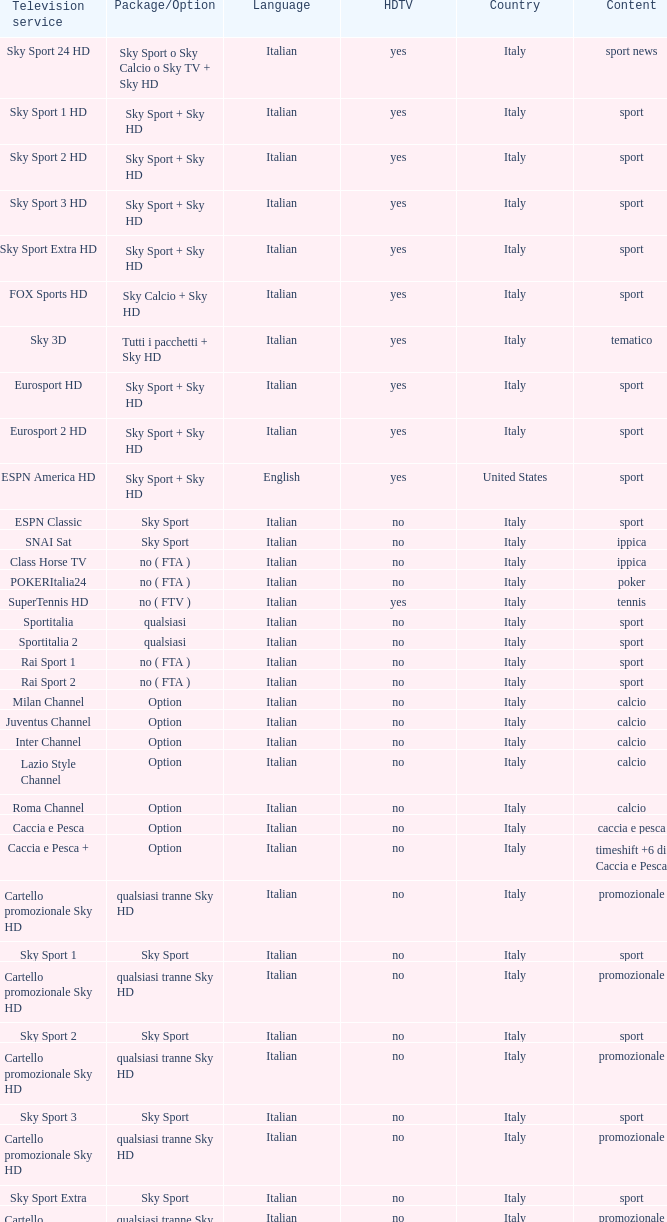What is Language, when Content is Sport, when HDTV is No, and when Television Service is ESPN America? Italian. 